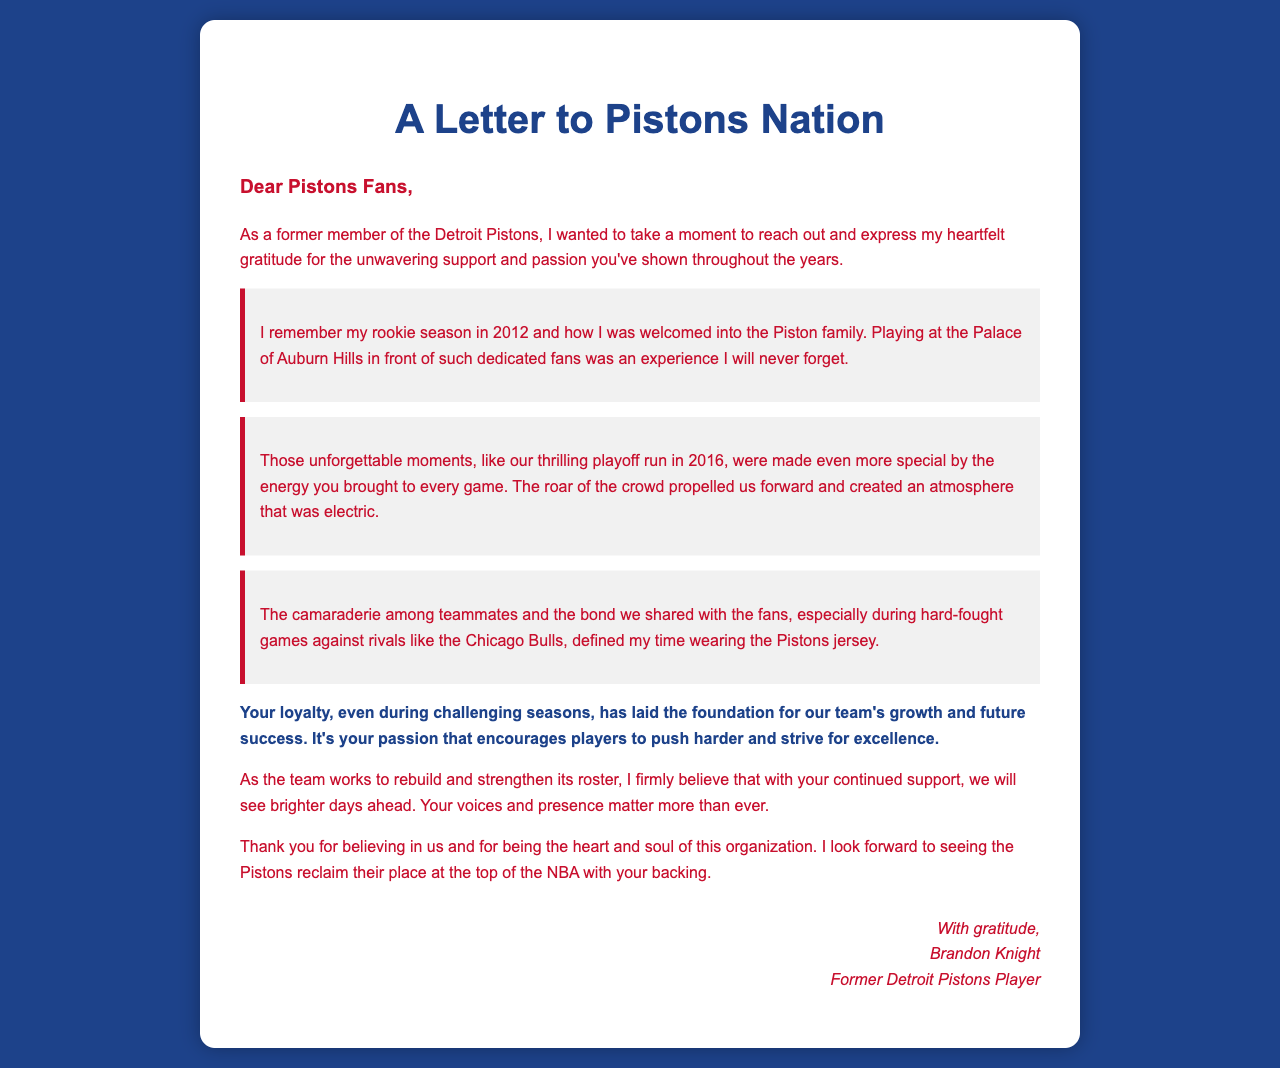what is the title of the letter? The title of the letter is displayed prominently at the top of the document as a main heading.
Answer: A Letter to Pistons Nation who wrote the letter? The letter is signed at the end, indicating the author is a former player of the team.
Answer: Brandon Knight in what year did Brandon Knight begin his rookie season? The document mentions the specific year when Brandon Knight joined the Pistons as a rookie.
Answer: 2012 what significant event is referenced in the letter that occurred in 2016? The document describes a notable achievement during a specific year in which the team had a successful run.
Answer: playoff run which fan experience is highlighted as special for Brandon Knight? The letter mentions a specific venue and fan interaction that enhanced the player's experience.
Answer: playing at the Palace of Auburn Hills what key quality does the letter attribute to the fan base? The document emphasizes an essential characteristic that is vital for the team's success during difficult times.
Answer: loyalty what phrase does Brandon Knight use to describe the fans' impact? The letter uses a specific expression to underline the significance of the fans’ presence in relation to team performance.
Answer: heart and soul how does Brandon Knight feel about the Pistons’ future? The document conveys a specific outlook regarding the team's upcoming potential based on past and current circumstances.
Answer: brighter days ahead 